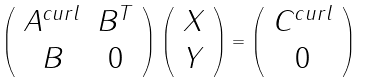<formula> <loc_0><loc_0><loc_500><loc_500>\left ( \begin{array} { c c c } A ^ { c u r l } & B ^ { T } \\ B & 0 \end{array} \right ) \left ( \begin{array} { c c c } X \\ Y \end{array} \right ) = \left ( \begin{array} { c c c } C ^ { c u r l } \\ 0 \end{array} \right )</formula> 